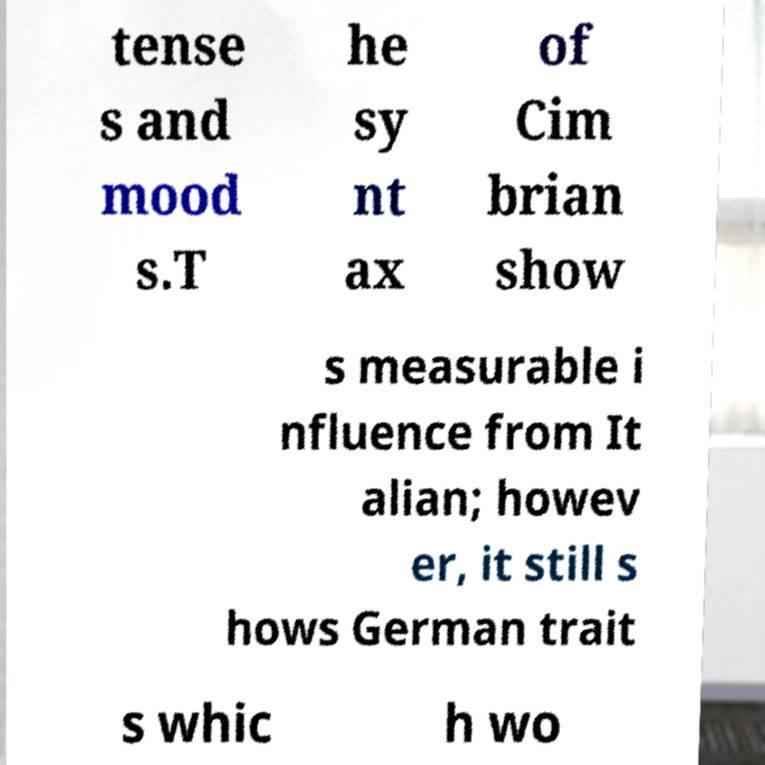Could you extract and type out the text from this image? tense s and mood s.T he sy nt ax of Cim brian show s measurable i nfluence from It alian; howev er, it still s hows German trait s whic h wo 